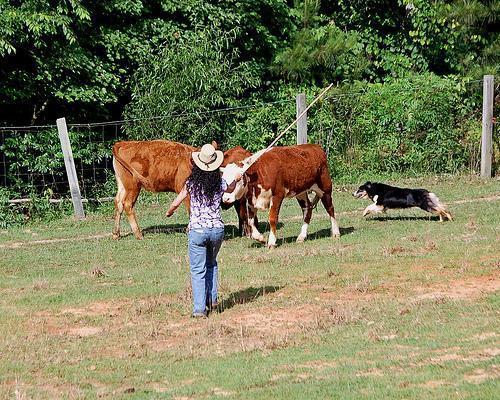How many animals are in this picture?
Give a very brief answer. 3. How many people are in this picture?
Give a very brief answer. 1. How many cows are there?
Give a very brief answer. 2. 